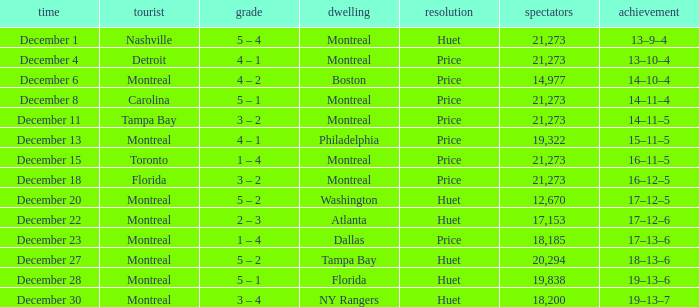What is the decision when the record is 13–10–4? Price. 